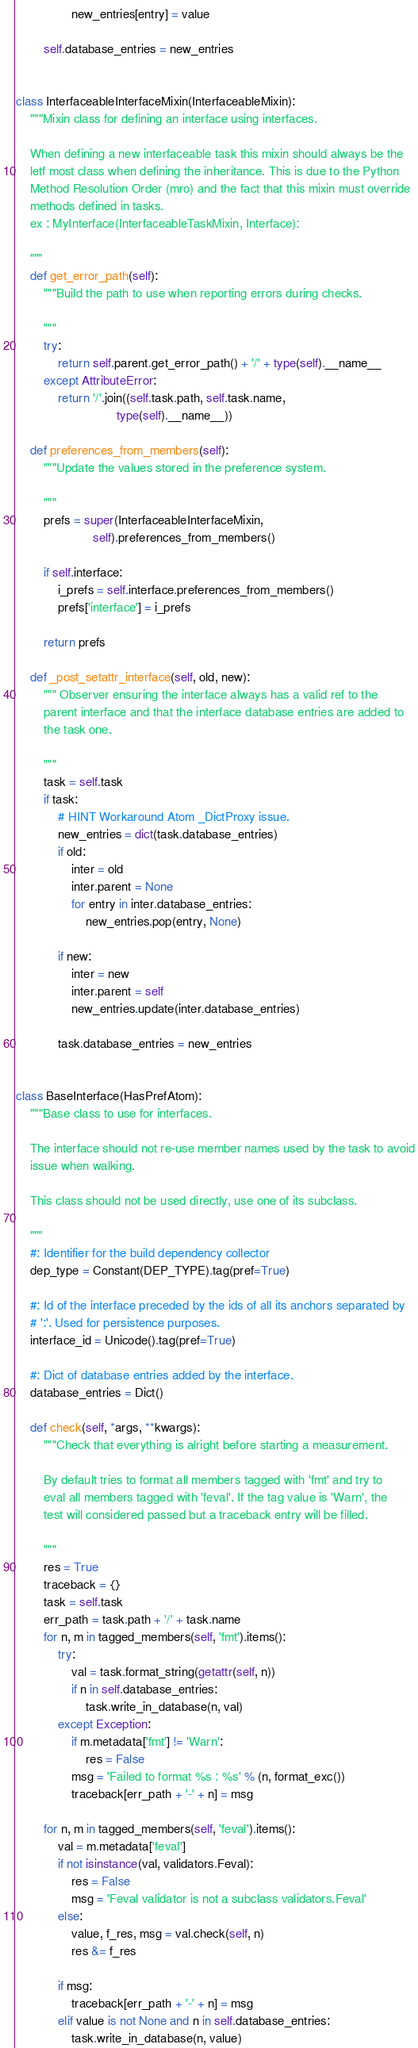<code> <loc_0><loc_0><loc_500><loc_500><_Python_>                new_entries[entry] = value

        self.database_entries = new_entries


class InterfaceableInterfaceMixin(InterfaceableMixin):
    """Mixin class for defining an interface using interfaces.

    When defining a new interfaceable task this mixin should always be the
    letf most class when defining the inheritance. This is due to the Python
    Method Resolution Order (mro) and the fact that this mixin must override
    methods defined in tasks.
    ex : MyInterface(InterfaceableTaskMixin, Interface):

    """
    def get_error_path(self):
        """Build the path to use when reporting errors during checks.

        """
        try:
            return self.parent.get_error_path() + '/' + type(self).__name__
        except AttributeError:
            return '/'.join((self.task.path, self.task.name,
                             type(self).__name__))

    def preferences_from_members(self):
        """Update the values stored in the preference system.

        """
        prefs = super(InterfaceableInterfaceMixin,
                      self).preferences_from_members()

        if self.interface:
            i_prefs = self.interface.preferences_from_members()
            prefs['interface'] = i_prefs

        return prefs

    def _post_setattr_interface(self, old, new):
        """ Observer ensuring the interface always has a valid ref to the
        parent interface and that the interface database entries are added to
        the task one.

        """
        task = self.task
        if task:
            # HINT Workaround Atom _DictProxy issue.
            new_entries = dict(task.database_entries)
            if old:
                inter = old
                inter.parent = None
                for entry in inter.database_entries:
                    new_entries.pop(entry, None)

            if new:
                inter = new
                inter.parent = self
                new_entries.update(inter.database_entries)

            task.database_entries = new_entries


class BaseInterface(HasPrefAtom):
    """Base class to use for interfaces.

    The interface should not re-use member names used by the task to avoid
    issue when walking.

    This class should not be used directly, use one of its subclass.

    """
    #: Identifier for the build dependency collector
    dep_type = Constant(DEP_TYPE).tag(pref=True)

    #: Id of the interface preceded by the ids of all its anchors separated by
    # ':'. Used for persistence purposes.
    interface_id = Unicode().tag(pref=True)

    #: Dict of database entries added by the interface.
    database_entries = Dict()

    def check(self, *args, **kwargs):
        """Check that everything is alright before starting a measurement.

        By default tries to format all members tagged with 'fmt' and try to
        eval all members tagged with 'feval'. If the tag value is 'Warn', the
        test will considered passed but a traceback entry will be filled.

        """
        res = True
        traceback = {}
        task = self.task
        err_path = task.path + '/' + task.name
        for n, m in tagged_members(self, 'fmt').items():
            try:
                val = task.format_string(getattr(self, n))
                if n in self.database_entries:
                    task.write_in_database(n, val)
            except Exception:
                if m.metadata['fmt'] != 'Warn':
                    res = False
                msg = 'Failed to format %s : %s' % (n, format_exc())
                traceback[err_path + '-' + n] = msg

        for n, m in tagged_members(self, 'feval').items():
            val = m.metadata['feval']
            if not isinstance(val, validators.Feval):
                res = False
                msg = 'Feval validator is not a subclass validators.Feval'
            else:
                value, f_res, msg = val.check(self, n)
                res &= f_res

            if msg:
                traceback[err_path + '-' + n] = msg
            elif value is not None and n in self.database_entries:
                task.write_in_database(n, value)
</code> 